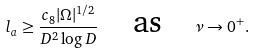Convert formula to latex. <formula><loc_0><loc_0><loc_500><loc_500>l _ { a } \geq \frac { c _ { 8 } | \Omega | ^ { 1 / 2 } } { D ^ { 2 } \log D } \, \quad \text {as} \quad \nu \to 0 ^ { + } .</formula> 